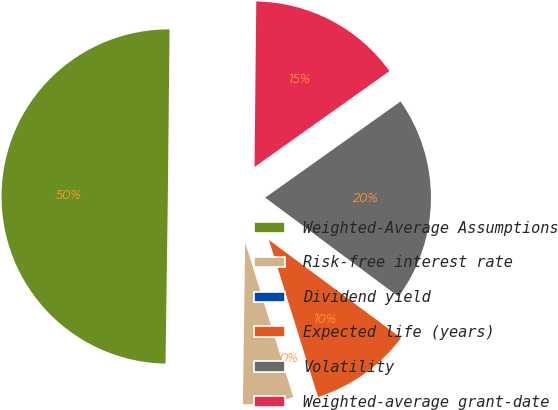Convert chart to OTSL. <chart><loc_0><loc_0><loc_500><loc_500><pie_chart><fcel>Weighted-Average Assumptions<fcel>Risk-free interest rate<fcel>Dividend yield<fcel>Expected life (years)<fcel>Volatility<fcel>Weighted-average grant-date<nl><fcel>49.93%<fcel>5.02%<fcel>0.03%<fcel>10.01%<fcel>19.99%<fcel>15.0%<nl></chart> 